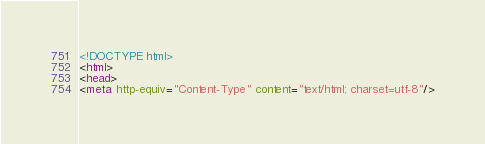<code> <loc_0><loc_0><loc_500><loc_500><_HTML_><!DOCTYPE html>
<html>
<head>
<meta http-equiv="Content-Type" content="text/html; charset=utf-8"/></code> 